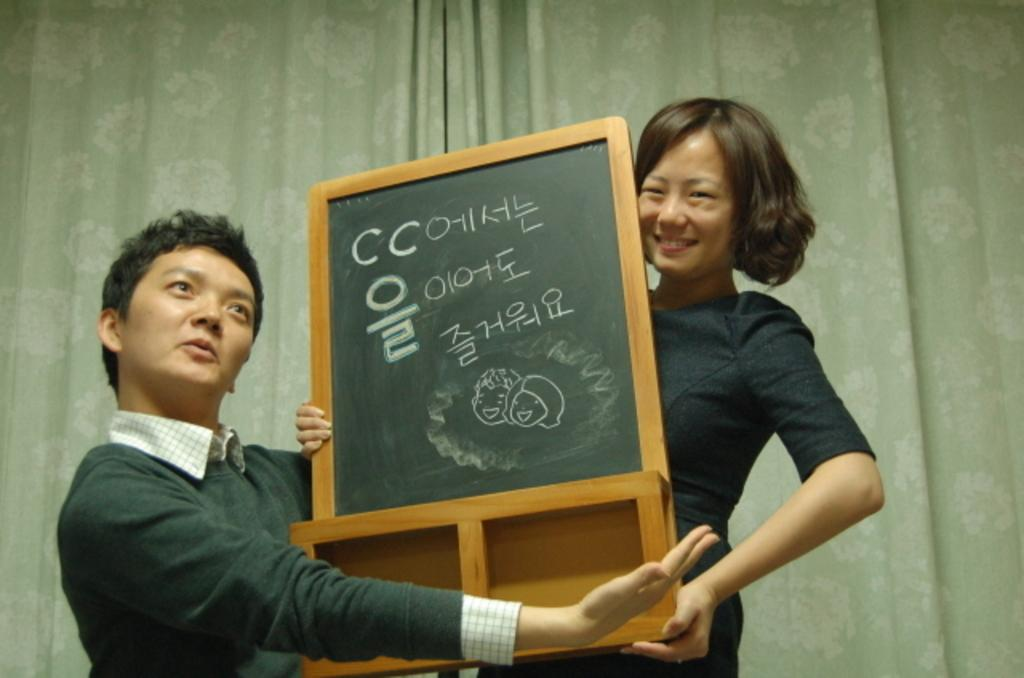How many people are in the image? There are two persons in the image. What are the persons doing in the image? The persons are standing in the image. What are the persons holding in the image? The persons are holding a wooden object in the image. What can be seen in the background of the image? There are curtains in the background of the image. What type of steel is visible in the image? There is no steel present in the image. Can you provide a list of the items in the image? The provided facts only mention two persons, their actions, the wooden object they are holding, and the curtains in the background. A complete list cannot be provided without additional information. 